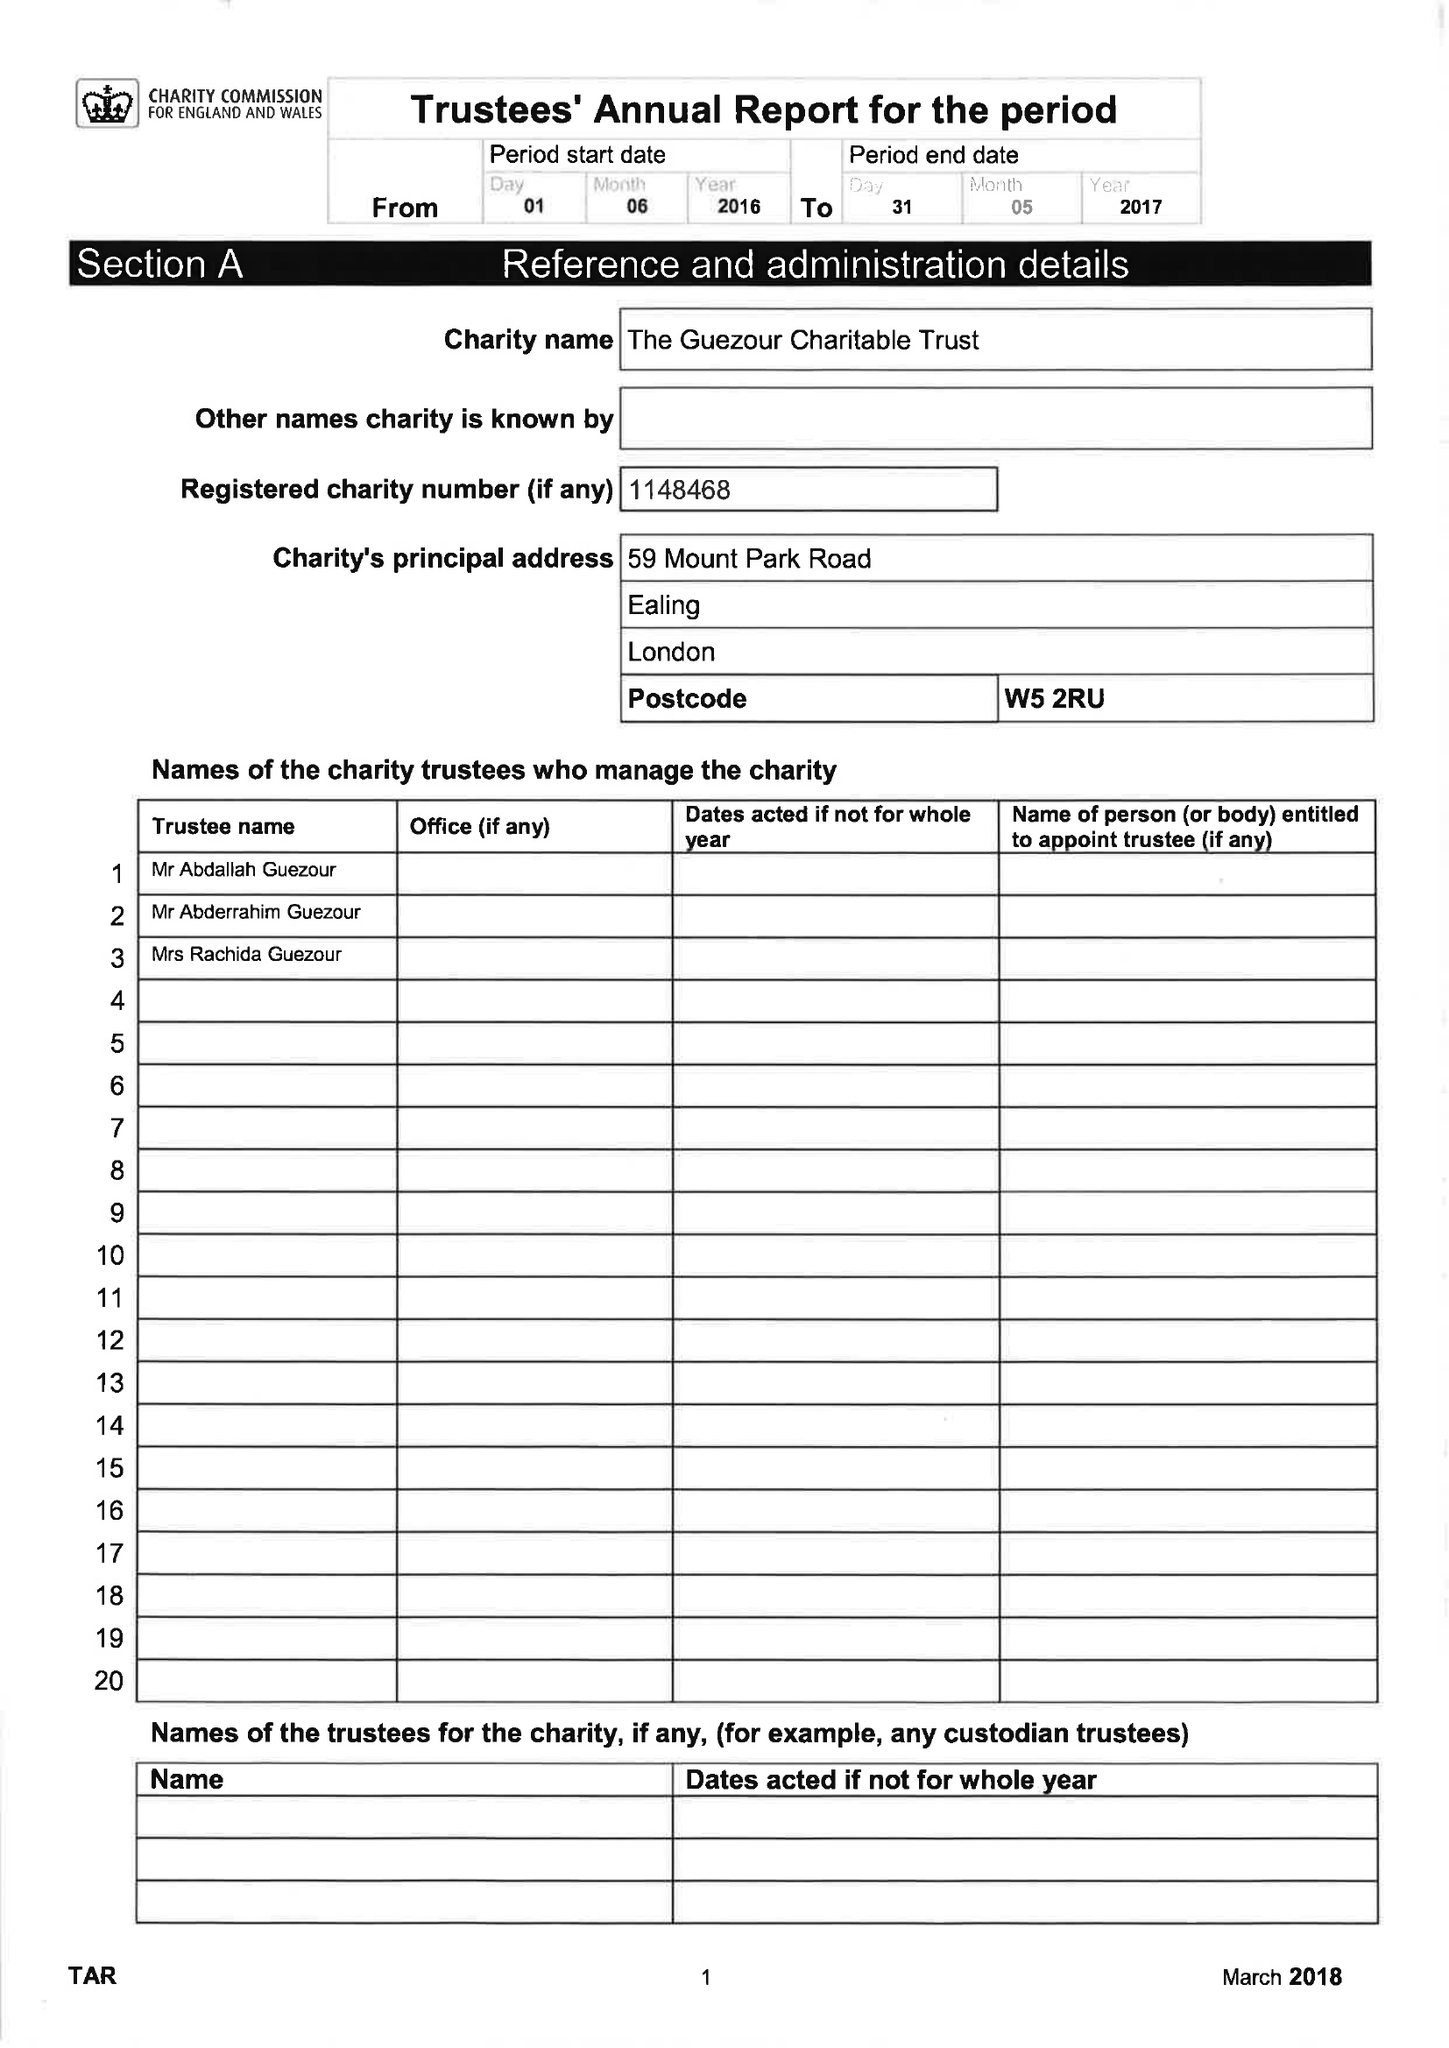What is the value for the charity_name?
Answer the question using a single word or phrase. The Guezour Charitable Trust 